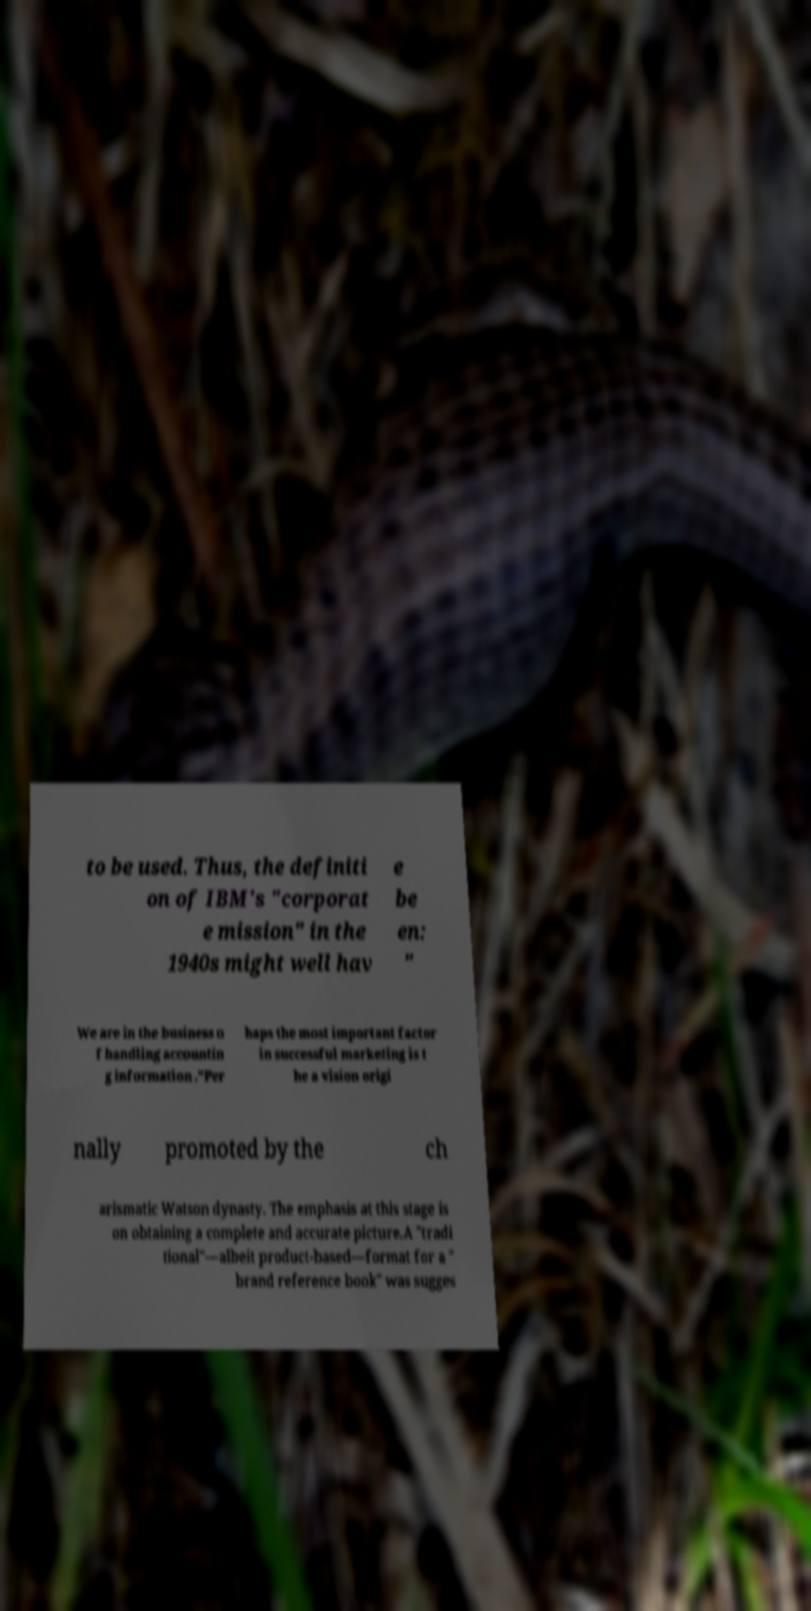Can you read and provide the text displayed in the image?This photo seems to have some interesting text. Can you extract and type it out for me? to be used. Thus, the definiti on of IBM's "corporat e mission" in the 1940s might well hav e be en: " We are in the business o f handling accountin g information ."Per haps the most important factor in successful marketing is t he a vision origi nally promoted by the ch arismatic Watson dynasty. The emphasis at this stage is on obtaining a complete and accurate picture.A "tradi tional"—albeit product-based—format for a " brand reference book" was sugges 